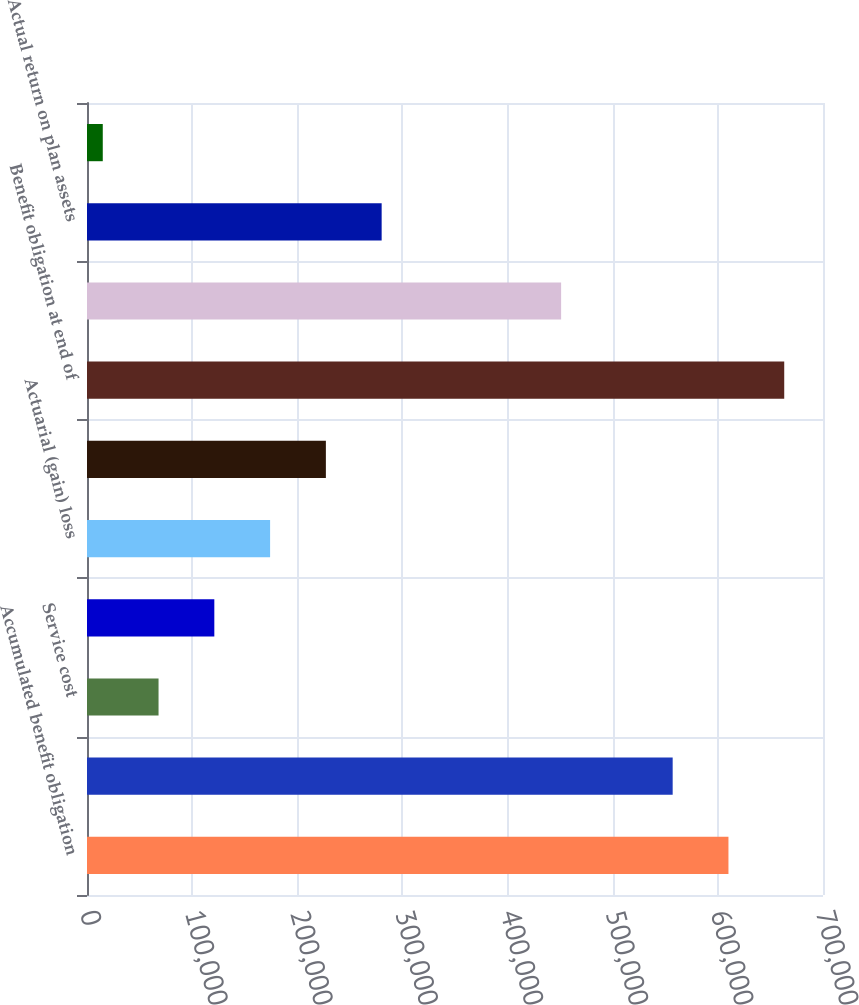Convert chart to OTSL. <chart><loc_0><loc_0><loc_500><loc_500><bar_chart><fcel>Accumulated benefit obligation<fcel>Benefit obligation at<fcel>Service cost<fcel>Interest cost<fcel>Actuarial (gain) loss<fcel>Benefits paid (1)<fcel>Benefit obligation at end of<fcel>Fair value of plan assets at<fcel>Actual return on plan assets<fcel>Employer contributions<nl><fcel>610076<fcel>557028<fcel>68048<fcel>121096<fcel>174144<fcel>227192<fcel>663124<fcel>450932<fcel>280240<fcel>15000<nl></chart> 